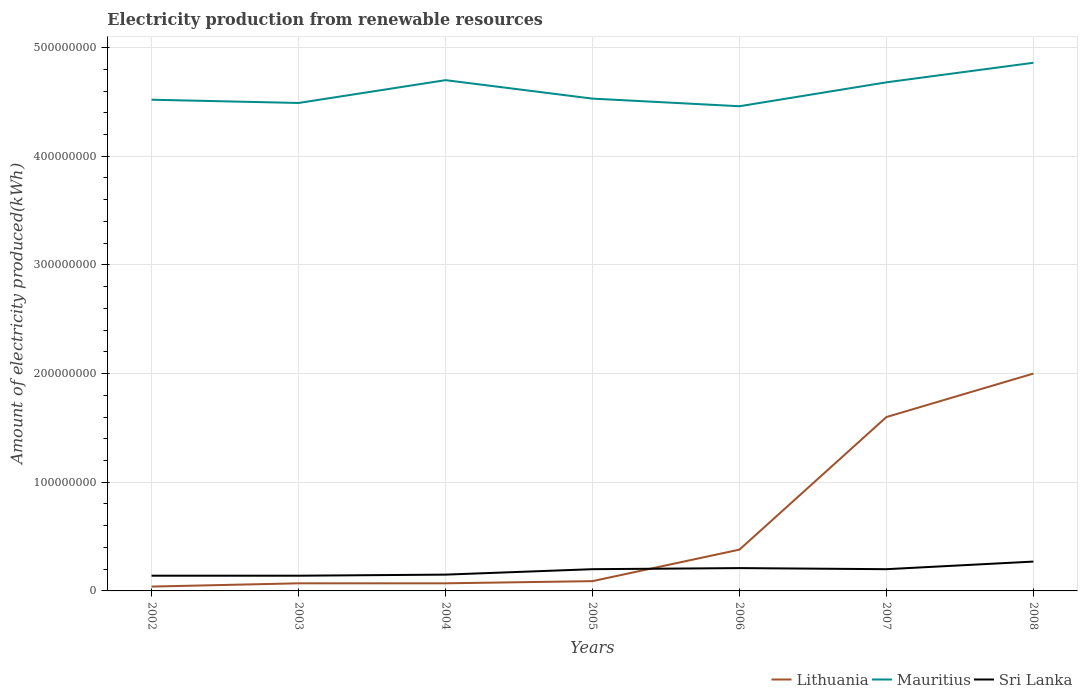How many different coloured lines are there?
Keep it short and to the point. 3. Does the line corresponding to Lithuania intersect with the line corresponding to Mauritius?
Give a very brief answer. No. Across all years, what is the maximum amount of electricity produced in Mauritius?
Your answer should be very brief. 4.46e+08. In which year was the amount of electricity produced in Sri Lanka maximum?
Make the answer very short. 2002. What is the total amount of electricity produced in Mauritius in the graph?
Give a very brief answer. -1.50e+07. What is the difference between the highest and the second highest amount of electricity produced in Sri Lanka?
Provide a succinct answer. 1.30e+07. What is the difference between the highest and the lowest amount of electricity produced in Sri Lanka?
Ensure brevity in your answer.  4. How many lines are there?
Offer a very short reply. 3. How many years are there in the graph?
Offer a very short reply. 7. Are the values on the major ticks of Y-axis written in scientific E-notation?
Provide a short and direct response. No. Does the graph contain any zero values?
Your response must be concise. No. Does the graph contain grids?
Provide a succinct answer. Yes. Where does the legend appear in the graph?
Your answer should be very brief. Bottom right. How are the legend labels stacked?
Ensure brevity in your answer.  Horizontal. What is the title of the graph?
Ensure brevity in your answer.  Electricity production from renewable resources. Does "Latin America(all income levels)" appear as one of the legend labels in the graph?
Provide a succinct answer. No. What is the label or title of the X-axis?
Offer a terse response. Years. What is the label or title of the Y-axis?
Provide a succinct answer. Amount of electricity produced(kWh). What is the Amount of electricity produced(kWh) of Mauritius in 2002?
Provide a succinct answer. 4.52e+08. What is the Amount of electricity produced(kWh) of Sri Lanka in 2002?
Ensure brevity in your answer.  1.40e+07. What is the Amount of electricity produced(kWh) in Lithuania in 2003?
Provide a short and direct response. 7.00e+06. What is the Amount of electricity produced(kWh) in Mauritius in 2003?
Ensure brevity in your answer.  4.49e+08. What is the Amount of electricity produced(kWh) in Sri Lanka in 2003?
Offer a very short reply. 1.40e+07. What is the Amount of electricity produced(kWh) of Lithuania in 2004?
Give a very brief answer. 7.00e+06. What is the Amount of electricity produced(kWh) of Mauritius in 2004?
Your answer should be very brief. 4.70e+08. What is the Amount of electricity produced(kWh) in Sri Lanka in 2004?
Offer a terse response. 1.50e+07. What is the Amount of electricity produced(kWh) of Lithuania in 2005?
Give a very brief answer. 9.00e+06. What is the Amount of electricity produced(kWh) in Mauritius in 2005?
Make the answer very short. 4.53e+08. What is the Amount of electricity produced(kWh) in Lithuania in 2006?
Your response must be concise. 3.80e+07. What is the Amount of electricity produced(kWh) in Mauritius in 2006?
Your answer should be very brief. 4.46e+08. What is the Amount of electricity produced(kWh) in Sri Lanka in 2006?
Provide a succinct answer. 2.10e+07. What is the Amount of electricity produced(kWh) in Lithuania in 2007?
Provide a short and direct response. 1.60e+08. What is the Amount of electricity produced(kWh) in Mauritius in 2007?
Ensure brevity in your answer.  4.68e+08. What is the Amount of electricity produced(kWh) of Sri Lanka in 2007?
Ensure brevity in your answer.  2.00e+07. What is the Amount of electricity produced(kWh) of Mauritius in 2008?
Offer a very short reply. 4.86e+08. What is the Amount of electricity produced(kWh) of Sri Lanka in 2008?
Provide a short and direct response. 2.70e+07. Across all years, what is the maximum Amount of electricity produced(kWh) of Mauritius?
Offer a terse response. 4.86e+08. Across all years, what is the maximum Amount of electricity produced(kWh) of Sri Lanka?
Provide a succinct answer. 2.70e+07. Across all years, what is the minimum Amount of electricity produced(kWh) of Mauritius?
Offer a terse response. 4.46e+08. Across all years, what is the minimum Amount of electricity produced(kWh) in Sri Lanka?
Keep it short and to the point. 1.40e+07. What is the total Amount of electricity produced(kWh) in Lithuania in the graph?
Make the answer very short. 4.25e+08. What is the total Amount of electricity produced(kWh) of Mauritius in the graph?
Provide a succinct answer. 3.22e+09. What is the total Amount of electricity produced(kWh) in Sri Lanka in the graph?
Your answer should be compact. 1.31e+08. What is the difference between the Amount of electricity produced(kWh) in Lithuania in 2002 and that in 2003?
Your answer should be compact. -3.00e+06. What is the difference between the Amount of electricity produced(kWh) of Sri Lanka in 2002 and that in 2003?
Your answer should be compact. 0. What is the difference between the Amount of electricity produced(kWh) in Mauritius in 2002 and that in 2004?
Make the answer very short. -1.80e+07. What is the difference between the Amount of electricity produced(kWh) in Sri Lanka in 2002 and that in 2004?
Your answer should be compact. -1.00e+06. What is the difference between the Amount of electricity produced(kWh) of Lithuania in 2002 and that in 2005?
Give a very brief answer. -5.00e+06. What is the difference between the Amount of electricity produced(kWh) of Mauritius in 2002 and that in 2005?
Provide a short and direct response. -1.00e+06. What is the difference between the Amount of electricity produced(kWh) in Sri Lanka in 2002 and that in 2005?
Provide a succinct answer. -6.00e+06. What is the difference between the Amount of electricity produced(kWh) in Lithuania in 2002 and that in 2006?
Provide a succinct answer. -3.40e+07. What is the difference between the Amount of electricity produced(kWh) in Mauritius in 2002 and that in 2006?
Offer a very short reply. 6.00e+06. What is the difference between the Amount of electricity produced(kWh) of Sri Lanka in 2002 and that in 2006?
Offer a very short reply. -7.00e+06. What is the difference between the Amount of electricity produced(kWh) of Lithuania in 2002 and that in 2007?
Offer a terse response. -1.56e+08. What is the difference between the Amount of electricity produced(kWh) of Mauritius in 2002 and that in 2007?
Provide a succinct answer. -1.60e+07. What is the difference between the Amount of electricity produced(kWh) of Sri Lanka in 2002 and that in 2007?
Make the answer very short. -6.00e+06. What is the difference between the Amount of electricity produced(kWh) of Lithuania in 2002 and that in 2008?
Offer a very short reply. -1.96e+08. What is the difference between the Amount of electricity produced(kWh) of Mauritius in 2002 and that in 2008?
Your answer should be very brief. -3.40e+07. What is the difference between the Amount of electricity produced(kWh) of Sri Lanka in 2002 and that in 2008?
Make the answer very short. -1.30e+07. What is the difference between the Amount of electricity produced(kWh) in Mauritius in 2003 and that in 2004?
Ensure brevity in your answer.  -2.10e+07. What is the difference between the Amount of electricity produced(kWh) of Sri Lanka in 2003 and that in 2004?
Your response must be concise. -1.00e+06. What is the difference between the Amount of electricity produced(kWh) in Lithuania in 2003 and that in 2005?
Your answer should be very brief. -2.00e+06. What is the difference between the Amount of electricity produced(kWh) in Mauritius in 2003 and that in 2005?
Offer a very short reply. -4.00e+06. What is the difference between the Amount of electricity produced(kWh) in Sri Lanka in 2003 and that in 2005?
Provide a short and direct response. -6.00e+06. What is the difference between the Amount of electricity produced(kWh) in Lithuania in 2003 and that in 2006?
Keep it short and to the point. -3.10e+07. What is the difference between the Amount of electricity produced(kWh) in Mauritius in 2003 and that in 2006?
Provide a succinct answer. 3.00e+06. What is the difference between the Amount of electricity produced(kWh) in Sri Lanka in 2003 and that in 2006?
Provide a succinct answer. -7.00e+06. What is the difference between the Amount of electricity produced(kWh) in Lithuania in 2003 and that in 2007?
Keep it short and to the point. -1.53e+08. What is the difference between the Amount of electricity produced(kWh) in Mauritius in 2003 and that in 2007?
Provide a short and direct response. -1.90e+07. What is the difference between the Amount of electricity produced(kWh) in Sri Lanka in 2003 and that in 2007?
Your response must be concise. -6.00e+06. What is the difference between the Amount of electricity produced(kWh) in Lithuania in 2003 and that in 2008?
Ensure brevity in your answer.  -1.93e+08. What is the difference between the Amount of electricity produced(kWh) of Mauritius in 2003 and that in 2008?
Provide a succinct answer. -3.70e+07. What is the difference between the Amount of electricity produced(kWh) in Sri Lanka in 2003 and that in 2008?
Offer a very short reply. -1.30e+07. What is the difference between the Amount of electricity produced(kWh) in Mauritius in 2004 and that in 2005?
Offer a very short reply. 1.70e+07. What is the difference between the Amount of electricity produced(kWh) in Sri Lanka in 2004 and that in 2005?
Make the answer very short. -5.00e+06. What is the difference between the Amount of electricity produced(kWh) of Lithuania in 2004 and that in 2006?
Keep it short and to the point. -3.10e+07. What is the difference between the Amount of electricity produced(kWh) in Mauritius in 2004 and that in 2006?
Provide a succinct answer. 2.40e+07. What is the difference between the Amount of electricity produced(kWh) of Sri Lanka in 2004 and that in 2006?
Keep it short and to the point. -6.00e+06. What is the difference between the Amount of electricity produced(kWh) of Lithuania in 2004 and that in 2007?
Your answer should be compact. -1.53e+08. What is the difference between the Amount of electricity produced(kWh) of Mauritius in 2004 and that in 2007?
Make the answer very short. 2.00e+06. What is the difference between the Amount of electricity produced(kWh) of Sri Lanka in 2004 and that in 2007?
Your answer should be very brief. -5.00e+06. What is the difference between the Amount of electricity produced(kWh) in Lithuania in 2004 and that in 2008?
Your response must be concise. -1.93e+08. What is the difference between the Amount of electricity produced(kWh) of Mauritius in 2004 and that in 2008?
Your answer should be compact. -1.60e+07. What is the difference between the Amount of electricity produced(kWh) in Sri Lanka in 2004 and that in 2008?
Your answer should be compact. -1.20e+07. What is the difference between the Amount of electricity produced(kWh) in Lithuania in 2005 and that in 2006?
Keep it short and to the point. -2.90e+07. What is the difference between the Amount of electricity produced(kWh) of Mauritius in 2005 and that in 2006?
Your answer should be very brief. 7.00e+06. What is the difference between the Amount of electricity produced(kWh) in Sri Lanka in 2005 and that in 2006?
Give a very brief answer. -1.00e+06. What is the difference between the Amount of electricity produced(kWh) of Lithuania in 2005 and that in 2007?
Give a very brief answer. -1.51e+08. What is the difference between the Amount of electricity produced(kWh) of Mauritius in 2005 and that in 2007?
Your answer should be compact. -1.50e+07. What is the difference between the Amount of electricity produced(kWh) in Lithuania in 2005 and that in 2008?
Offer a very short reply. -1.91e+08. What is the difference between the Amount of electricity produced(kWh) in Mauritius in 2005 and that in 2008?
Your answer should be compact. -3.30e+07. What is the difference between the Amount of electricity produced(kWh) of Sri Lanka in 2005 and that in 2008?
Ensure brevity in your answer.  -7.00e+06. What is the difference between the Amount of electricity produced(kWh) in Lithuania in 2006 and that in 2007?
Offer a very short reply. -1.22e+08. What is the difference between the Amount of electricity produced(kWh) in Mauritius in 2006 and that in 2007?
Your response must be concise. -2.20e+07. What is the difference between the Amount of electricity produced(kWh) in Sri Lanka in 2006 and that in 2007?
Make the answer very short. 1.00e+06. What is the difference between the Amount of electricity produced(kWh) of Lithuania in 2006 and that in 2008?
Your answer should be compact. -1.62e+08. What is the difference between the Amount of electricity produced(kWh) in Mauritius in 2006 and that in 2008?
Give a very brief answer. -4.00e+07. What is the difference between the Amount of electricity produced(kWh) of Sri Lanka in 2006 and that in 2008?
Provide a succinct answer. -6.00e+06. What is the difference between the Amount of electricity produced(kWh) in Lithuania in 2007 and that in 2008?
Offer a very short reply. -4.00e+07. What is the difference between the Amount of electricity produced(kWh) of Mauritius in 2007 and that in 2008?
Offer a very short reply. -1.80e+07. What is the difference between the Amount of electricity produced(kWh) in Sri Lanka in 2007 and that in 2008?
Your answer should be compact. -7.00e+06. What is the difference between the Amount of electricity produced(kWh) of Lithuania in 2002 and the Amount of electricity produced(kWh) of Mauritius in 2003?
Make the answer very short. -4.45e+08. What is the difference between the Amount of electricity produced(kWh) of Lithuania in 2002 and the Amount of electricity produced(kWh) of Sri Lanka in 2003?
Provide a short and direct response. -1.00e+07. What is the difference between the Amount of electricity produced(kWh) of Mauritius in 2002 and the Amount of electricity produced(kWh) of Sri Lanka in 2003?
Ensure brevity in your answer.  4.38e+08. What is the difference between the Amount of electricity produced(kWh) of Lithuania in 2002 and the Amount of electricity produced(kWh) of Mauritius in 2004?
Provide a short and direct response. -4.66e+08. What is the difference between the Amount of electricity produced(kWh) in Lithuania in 2002 and the Amount of electricity produced(kWh) in Sri Lanka in 2004?
Keep it short and to the point. -1.10e+07. What is the difference between the Amount of electricity produced(kWh) of Mauritius in 2002 and the Amount of electricity produced(kWh) of Sri Lanka in 2004?
Your answer should be very brief. 4.37e+08. What is the difference between the Amount of electricity produced(kWh) in Lithuania in 2002 and the Amount of electricity produced(kWh) in Mauritius in 2005?
Your answer should be very brief. -4.49e+08. What is the difference between the Amount of electricity produced(kWh) of Lithuania in 2002 and the Amount of electricity produced(kWh) of Sri Lanka in 2005?
Make the answer very short. -1.60e+07. What is the difference between the Amount of electricity produced(kWh) in Mauritius in 2002 and the Amount of electricity produced(kWh) in Sri Lanka in 2005?
Ensure brevity in your answer.  4.32e+08. What is the difference between the Amount of electricity produced(kWh) of Lithuania in 2002 and the Amount of electricity produced(kWh) of Mauritius in 2006?
Your answer should be compact. -4.42e+08. What is the difference between the Amount of electricity produced(kWh) in Lithuania in 2002 and the Amount of electricity produced(kWh) in Sri Lanka in 2006?
Make the answer very short. -1.70e+07. What is the difference between the Amount of electricity produced(kWh) of Mauritius in 2002 and the Amount of electricity produced(kWh) of Sri Lanka in 2006?
Your answer should be very brief. 4.31e+08. What is the difference between the Amount of electricity produced(kWh) of Lithuania in 2002 and the Amount of electricity produced(kWh) of Mauritius in 2007?
Give a very brief answer. -4.64e+08. What is the difference between the Amount of electricity produced(kWh) in Lithuania in 2002 and the Amount of electricity produced(kWh) in Sri Lanka in 2007?
Your answer should be very brief. -1.60e+07. What is the difference between the Amount of electricity produced(kWh) in Mauritius in 2002 and the Amount of electricity produced(kWh) in Sri Lanka in 2007?
Your response must be concise. 4.32e+08. What is the difference between the Amount of electricity produced(kWh) of Lithuania in 2002 and the Amount of electricity produced(kWh) of Mauritius in 2008?
Keep it short and to the point. -4.82e+08. What is the difference between the Amount of electricity produced(kWh) in Lithuania in 2002 and the Amount of electricity produced(kWh) in Sri Lanka in 2008?
Offer a terse response. -2.30e+07. What is the difference between the Amount of electricity produced(kWh) in Mauritius in 2002 and the Amount of electricity produced(kWh) in Sri Lanka in 2008?
Your response must be concise. 4.25e+08. What is the difference between the Amount of electricity produced(kWh) in Lithuania in 2003 and the Amount of electricity produced(kWh) in Mauritius in 2004?
Provide a short and direct response. -4.63e+08. What is the difference between the Amount of electricity produced(kWh) in Lithuania in 2003 and the Amount of electricity produced(kWh) in Sri Lanka in 2004?
Keep it short and to the point. -8.00e+06. What is the difference between the Amount of electricity produced(kWh) in Mauritius in 2003 and the Amount of electricity produced(kWh) in Sri Lanka in 2004?
Make the answer very short. 4.34e+08. What is the difference between the Amount of electricity produced(kWh) in Lithuania in 2003 and the Amount of electricity produced(kWh) in Mauritius in 2005?
Your response must be concise. -4.46e+08. What is the difference between the Amount of electricity produced(kWh) in Lithuania in 2003 and the Amount of electricity produced(kWh) in Sri Lanka in 2005?
Ensure brevity in your answer.  -1.30e+07. What is the difference between the Amount of electricity produced(kWh) of Mauritius in 2003 and the Amount of electricity produced(kWh) of Sri Lanka in 2005?
Give a very brief answer. 4.29e+08. What is the difference between the Amount of electricity produced(kWh) of Lithuania in 2003 and the Amount of electricity produced(kWh) of Mauritius in 2006?
Offer a very short reply. -4.39e+08. What is the difference between the Amount of electricity produced(kWh) of Lithuania in 2003 and the Amount of electricity produced(kWh) of Sri Lanka in 2006?
Provide a short and direct response. -1.40e+07. What is the difference between the Amount of electricity produced(kWh) in Mauritius in 2003 and the Amount of electricity produced(kWh) in Sri Lanka in 2006?
Your response must be concise. 4.28e+08. What is the difference between the Amount of electricity produced(kWh) of Lithuania in 2003 and the Amount of electricity produced(kWh) of Mauritius in 2007?
Make the answer very short. -4.61e+08. What is the difference between the Amount of electricity produced(kWh) in Lithuania in 2003 and the Amount of electricity produced(kWh) in Sri Lanka in 2007?
Give a very brief answer. -1.30e+07. What is the difference between the Amount of electricity produced(kWh) of Mauritius in 2003 and the Amount of electricity produced(kWh) of Sri Lanka in 2007?
Keep it short and to the point. 4.29e+08. What is the difference between the Amount of electricity produced(kWh) of Lithuania in 2003 and the Amount of electricity produced(kWh) of Mauritius in 2008?
Make the answer very short. -4.79e+08. What is the difference between the Amount of electricity produced(kWh) in Lithuania in 2003 and the Amount of electricity produced(kWh) in Sri Lanka in 2008?
Offer a very short reply. -2.00e+07. What is the difference between the Amount of electricity produced(kWh) in Mauritius in 2003 and the Amount of electricity produced(kWh) in Sri Lanka in 2008?
Your response must be concise. 4.22e+08. What is the difference between the Amount of electricity produced(kWh) of Lithuania in 2004 and the Amount of electricity produced(kWh) of Mauritius in 2005?
Provide a succinct answer. -4.46e+08. What is the difference between the Amount of electricity produced(kWh) in Lithuania in 2004 and the Amount of electricity produced(kWh) in Sri Lanka in 2005?
Keep it short and to the point. -1.30e+07. What is the difference between the Amount of electricity produced(kWh) of Mauritius in 2004 and the Amount of electricity produced(kWh) of Sri Lanka in 2005?
Provide a succinct answer. 4.50e+08. What is the difference between the Amount of electricity produced(kWh) of Lithuania in 2004 and the Amount of electricity produced(kWh) of Mauritius in 2006?
Ensure brevity in your answer.  -4.39e+08. What is the difference between the Amount of electricity produced(kWh) of Lithuania in 2004 and the Amount of electricity produced(kWh) of Sri Lanka in 2006?
Ensure brevity in your answer.  -1.40e+07. What is the difference between the Amount of electricity produced(kWh) of Mauritius in 2004 and the Amount of electricity produced(kWh) of Sri Lanka in 2006?
Offer a terse response. 4.49e+08. What is the difference between the Amount of electricity produced(kWh) of Lithuania in 2004 and the Amount of electricity produced(kWh) of Mauritius in 2007?
Your response must be concise. -4.61e+08. What is the difference between the Amount of electricity produced(kWh) of Lithuania in 2004 and the Amount of electricity produced(kWh) of Sri Lanka in 2007?
Provide a succinct answer. -1.30e+07. What is the difference between the Amount of electricity produced(kWh) of Mauritius in 2004 and the Amount of electricity produced(kWh) of Sri Lanka in 2007?
Offer a terse response. 4.50e+08. What is the difference between the Amount of electricity produced(kWh) in Lithuania in 2004 and the Amount of electricity produced(kWh) in Mauritius in 2008?
Ensure brevity in your answer.  -4.79e+08. What is the difference between the Amount of electricity produced(kWh) of Lithuania in 2004 and the Amount of electricity produced(kWh) of Sri Lanka in 2008?
Offer a very short reply. -2.00e+07. What is the difference between the Amount of electricity produced(kWh) in Mauritius in 2004 and the Amount of electricity produced(kWh) in Sri Lanka in 2008?
Make the answer very short. 4.43e+08. What is the difference between the Amount of electricity produced(kWh) of Lithuania in 2005 and the Amount of electricity produced(kWh) of Mauritius in 2006?
Offer a very short reply. -4.37e+08. What is the difference between the Amount of electricity produced(kWh) of Lithuania in 2005 and the Amount of electricity produced(kWh) of Sri Lanka in 2006?
Your answer should be compact. -1.20e+07. What is the difference between the Amount of electricity produced(kWh) in Mauritius in 2005 and the Amount of electricity produced(kWh) in Sri Lanka in 2006?
Provide a short and direct response. 4.32e+08. What is the difference between the Amount of electricity produced(kWh) in Lithuania in 2005 and the Amount of electricity produced(kWh) in Mauritius in 2007?
Your response must be concise. -4.59e+08. What is the difference between the Amount of electricity produced(kWh) of Lithuania in 2005 and the Amount of electricity produced(kWh) of Sri Lanka in 2007?
Offer a very short reply. -1.10e+07. What is the difference between the Amount of electricity produced(kWh) in Mauritius in 2005 and the Amount of electricity produced(kWh) in Sri Lanka in 2007?
Ensure brevity in your answer.  4.33e+08. What is the difference between the Amount of electricity produced(kWh) of Lithuania in 2005 and the Amount of electricity produced(kWh) of Mauritius in 2008?
Offer a very short reply. -4.77e+08. What is the difference between the Amount of electricity produced(kWh) of Lithuania in 2005 and the Amount of electricity produced(kWh) of Sri Lanka in 2008?
Your answer should be very brief. -1.80e+07. What is the difference between the Amount of electricity produced(kWh) in Mauritius in 2005 and the Amount of electricity produced(kWh) in Sri Lanka in 2008?
Your answer should be very brief. 4.26e+08. What is the difference between the Amount of electricity produced(kWh) of Lithuania in 2006 and the Amount of electricity produced(kWh) of Mauritius in 2007?
Offer a very short reply. -4.30e+08. What is the difference between the Amount of electricity produced(kWh) in Lithuania in 2006 and the Amount of electricity produced(kWh) in Sri Lanka in 2007?
Offer a very short reply. 1.80e+07. What is the difference between the Amount of electricity produced(kWh) of Mauritius in 2006 and the Amount of electricity produced(kWh) of Sri Lanka in 2007?
Your response must be concise. 4.26e+08. What is the difference between the Amount of electricity produced(kWh) in Lithuania in 2006 and the Amount of electricity produced(kWh) in Mauritius in 2008?
Your answer should be very brief. -4.48e+08. What is the difference between the Amount of electricity produced(kWh) of Lithuania in 2006 and the Amount of electricity produced(kWh) of Sri Lanka in 2008?
Ensure brevity in your answer.  1.10e+07. What is the difference between the Amount of electricity produced(kWh) in Mauritius in 2006 and the Amount of electricity produced(kWh) in Sri Lanka in 2008?
Keep it short and to the point. 4.19e+08. What is the difference between the Amount of electricity produced(kWh) in Lithuania in 2007 and the Amount of electricity produced(kWh) in Mauritius in 2008?
Your answer should be compact. -3.26e+08. What is the difference between the Amount of electricity produced(kWh) in Lithuania in 2007 and the Amount of electricity produced(kWh) in Sri Lanka in 2008?
Offer a very short reply. 1.33e+08. What is the difference between the Amount of electricity produced(kWh) of Mauritius in 2007 and the Amount of electricity produced(kWh) of Sri Lanka in 2008?
Make the answer very short. 4.41e+08. What is the average Amount of electricity produced(kWh) in Lithuania per year?
Ensure brevity in your answer.  6.07e+07. What is the average Amount of electricity produced(kWh) of Mauritius per year?
Your answer should be compact. 4.61e+08. What is the average Amount of electricity produced(kWh) in Sri Lanka per year?
Provide a succinct answer. 1.87e+07. In the year 2002, what is the difference between the Amount of electricity produced(kWh) in Lithuania and Amount of electricity produced(kWh) in Mauritius?
Your answer should be compact. -4.48e+08. In the year 2002, what is the difference between the Amount of electricity produced(kWh) of Lithuania and Amount of electricity produced(kWh) of Sri Lanka?
Ensure brevity in your answer.  -1.00e+07. In the year 2002, what is the difference between the Amount of electricity produced(kWh) of Mauritius and Amount of electricity produced(kWh) of Sri Lanka?
Your answer should be very brief. 4.38e+08. In the year 2003, what is the difference between the Amount of electricity produced(kWh) in Lithuania and Amount of electricity produced(kWh) in Mauritius?
Provide a succinct answer. -4.42e+08. In the year 2003, what is the difference between the Amount of electricity produced(kWh) in Lithuania and Amount of electricity produced(kWh) in Sri Lanka?
Your answer should be compact. -7.00e+06. In the year 2003, what is the difference between the Amount of electricity produced(kWh) in Mauritius and Amount of electricity produced(kWh) in Sri Lanka?
Offer a very short reply. 4.35e+08. In the year 2004, what is the difference between the Amount of electricity produced(kWh) in Lithuania and Amount of electricity produced(kWh) in Mauritius?
Your response must be concise. -4.63e+08. In the year 2004, what is the difference between the Amount of electricity produced(kWh) of Lithuania and Amount of electricity produced(kWh) of Sri Lanka?
Offer a terse response. -8.00e+06. In the year 2004, what is the difference between the Amount of electricity produced(kWh) of Mauritius and Amount of electricity produced(kWh) of Sri Lanka?
Give a very brief answer. 4.55e+08. In the year 2005, what is the difference between the Amount of electricity produced(kWh) in Lithuania and Amount of electricity produced(kWh) in Mauritius?
Give a very brief answer. -4.44e+08. In the year 2005, what is the difference between the Amount of electricity produced(kWh) in Lithuania and Amount of electricity produced(kWh) in Sri Lanka?
Make the answer very short. -1.10e+07. In the year 2005, what is the difference between the Amount of electricity produced(kWh) of Mauritius and Amount of electricity produced(kWh) of Sri Lanka?
Provide a succinct answer. 4.33e+08. In the year 2006, what is the difference between the Amount of electricity produced(kWh) in Lithuania and Amount of electricity produced(kWh) in Mauritius?
Give a very brief answer. -4.08e+08. In the year 2006, what is the difference between the Amount of electricity produced(kWh) in Lithuania and Amount of electricity produced(kWh) in Sri Lanka?
Your response must be concise. 1.70e+07. In the year 2006, what is the difference between the Amount of electricity produced(kWh) of Mauritius and Amount of electricity produced(kWh) of Sri Lanka?
Your response must be concise. 4.25e+08. In the year 2007, what is the difference between the Amount of electricity produced(kWh) of Lithuania and Amount of electricity produced(kWh) of Mauritius?
Provide a succinct answer. -3.08e+08. In the year 2007, what is the difference between the Amount of electricity produced(kWh) in Lithuania and Amount of electricity produced(kWh) in Sri Lanka?
Keep it short and to the point. 1.40e+08. In the year 2007, what is the difference between the Amount of electricity produced(kWh) in Mauritius and Amount of electricity produced(kWh) in Sri Lanka?
Give a very brief answer. 4.48e+08. In the year 2008, what is the difference between the Amount of electricity produced(kWh) in Lithuania and Amount of electricity produced(kWh) in Mauritius?
Keep it short and to the point. -2.86e+08. In the year 2008, what is the difference between the Amount of electricity produced(kWh) in Lithuania and Amount of electricity produced(kWh) in Sri Lanka?
Provide a succinct answer. 1.73e+08. In the year 2008, what is the difference between the Amount of electricity produced(kWh) of Mauritius and Amount of electricity produced(kWh) of Sri Lanka?
Your response must be concise. 4.59e+08. What is the ratio of the Amount of electricity produced(kWh) in Lithuania in 2002 to that in 2003?
Offer a very short reply. 0.57. What is the ratio of the Amount of electricity produced(kWh) in Mauritius in 2002 to that in 2003?
Provide a succinct answer. 1.01. What is the ratio of the Amount of electricity produced(kWh) of Sri Lanka in 2002 to that in 2003?
Ensure brevity in your answer.  1. What is the ratio of the Amount of electricity produced(kWh) of Mauritius in 2002 to that in 2004?
Provide a succinct answer. 0.96. What is the ratio of the Amount of electricity produced(kWh) in Sri Lanka in 2002 to that in 2004?
Keep it short and to the point. 0.93. What is the ratio of the Amount of electricity produced(kWh) of Lithuania in 2002 to that in 2005?
Your response must be concise. 0.44. What is the ratio of the Amount of electricity produced(kWh) of Lithuania in 2002 to that in 2006?
Make the answer very short. 0.11. What is the ratio of the Amount of electricity produced(kWh) in Mauritius in 2002 to that in 2006?
Offer a very short reply. 1.01. What is the ratio of the Amount of electricity produced(kWh) of Sri Lanka in 2002 to that in 2006?
Offer a terse response. 0.67. What is the ratio of the Amount of electricity produced(kWh) in Lithuania in 2002 to that in 2007?
Ensure brevity in your answer.  0.03. What is the ratio of the Amount of electricity produced(kWh) of Mauritius in 2002 to that in 2007?
Give a very brief answer. 0.97. What is the ratio of the Amount of electricity produced(kWh) of Sri Lanka in 2002 to that in 2007?
Provide a succinct answer. 0.7. What is the ratio of the Amount of electricity produced(kWh) in Lithuania in 2002 to that in 2008?
Your response must be concise. 0.02. What is the ratio of the Amount of electricity produced(kWh) in Sri Lanka in 2002 to that in 2008?
Offer a terse response. 0.52. What is the ratio of the Amount of electricity produced(kWh) of Mauritius in 2003 to that in 2004?
Offer a very short reply. 0.96. What is the ratio of the Amount of electricity produced(kWh) of Sri Lanka in 2003 to that in 2004?
Provide a succinct answer. 0.93. What is the ratio of the Amount of electricity produced(kWh) of Lithuania in 2003 to that in 2005?
Your answer should be compact. 0.78. What is the ratio of the Amount of electricity produced(kWh) in Mauritius in 2003 to that in 2005?
Give a very brief answer. 0.99. What is the ratio of the Amount of electricity produced(kWh) of Lithuania in 2003 to that in 2006?
Keep it short and to the point. 0.18. What is the ratio of the Amount of electricity produced(kWh) of Sri Lanka in 2003 to that in 2006?
Offer a terse response. 0.67. What is the ratio of the Amount of electricity produced(kWh) of Lithuania in 2003 to that in 2007?
Give a very brief answer. 0.04. What is the ratio of the Amount of electricity produced(kWh) in Mauritius in 2003 to that in 2007?
Offer a terse response. 0.96. What is the ratio of the Amount of electricity produced(kWh) of Sri Lanka in 2003 to that in 2007?
Offer a terse response. 0.7. What is the ratio of the Amount of electricity produced(kWh) in Lithuania in 2003 to that in 2008?
Offer a very short reply. 0.04. What is the ratio of the Amount of electricity produced(kWh) in Mauritius in 2003 to that in 2008?
Provide a succinct answer. 0.92. What is the ratio of the Amount of electricity produced(kWh) in Sri Lanka in 2003 to that in 2008?
Provide a succinct answer. 0.52. What is the ratio of the Amount of electricity produced(kWh) in Lithuania in 2004 to that in 2005?
Offer a terse response. 0.78. What is the ratio of the Amount of electricity produced(kWh) of Mauritius in 2004 to that in 2005?
Give a very brief answer. 1.04. What is the ratio of the Amount of electricity produced(kWh) in Lithuania in 2004 to that in 2006?
Provide a short and direct response. 0.18. What is the ratio of the Amount of electricity produced(kWh) in Mauritius in 2004 to that in 2006?
Make the answer very short. 1.05. What is the ratio of the Amount of electricity produced(kWh) of Lithuania in 2004 to that in 2007?
Ensure brevity in your answer.  0.04. What is the ratio of the Amount of electricity produced(kWh) of Mauritius in 2004 to that in 2007?
Ensure brevity in your answer.  1. What is the ratio of the Amount of electricity produced(kWh) in Lithuania in 2004 to that in 2008?
Your answer should be very brief. 0.04. What is the ratio of the Amount of electricity produced(kWh) in Mauritius in 2004 to that in 2008?
Your answer should be compact. 0.97. What is the ratio of the Amount of electricity produced(kWh) in Sri Lanka in 2004 to that in 2008?
Make the answer very short. 0.56. What is the ratio of the Amount of electricity produced(kWh) in Lithuania in 2005 to that in 2006?
Provide a short and direct response. 0.24. What is the ratio of the Amount of electricity produced(kWh) of Mauritius in 2005 to that in 2006?
Make the answer very short. 1.02. What is the ratio of the Amount of electricity produced(kWh) of Sri Lanka in 2005 to that in 2006?
Provide a succinct answer. 0.95. What is the ratio of the Amount of electricity produced(kWh) in Lithuania in 2005 to that in 2007?
Your answer should be compact. 0.06. What is the ratio of the Amount of electricity produced(kWh) of Mauritius in 2005 to that in 2007?
Keep it short and to the point. 0.97. What is the ratio of the Amount of electricity produced(kWh) in Sri Lanka in 2005 to that in 2007?
Ensure brevity in your answer.  1. What is the ratio of the Amount of electricity produced(kWh) of Lithuania in 2005 to that in 2008?
Keep it short and to the point. 0.04. What is the ratio of the Amount of electricity produced(kWh) of Mauritius in 2005 to that in 2008?
Offer a terse response. 0.93. What is the ratio of the Amount of electricity produced(kWh) of Sri Lanka in 2005 to that in 2008?
Provide a succinct answer. 0.74. What is the ratio of the Amount of electricity produced(kWh) of Lithuania in 2006 to that in 2007?
Offer a very short reply. 0.24. What is the ratio of the Amount of electricity produced(kWh) in Mauritius in 2006 to that in 2007?
Offer a terse response. 0.95. What is the ratio of the Amount of electricity produced(kWh) in Sri Lanka in 2006 to that in 2007?
Make the answer very short. 1.05. What is the ratio of the Amount of electricity produced(kWh) in Lithuania in 2006 to that in 2008?
Provide a short and direct response. 0.19. What is the ratio of the Amount of electricity produced(kWh) in Mauritius in 2006 to that in 2008?
Provide a succinct answer. 0.92. What is the ratio of the Amount of electricity produced(kWh) in Mauritius in 2007 to that in 2008?
Offer a very short reply. 0.96. What is the ratio of the Amount of electricity produced(kWh) in Sri Lanka in 2007 to that in 2008?
Provide a succinct answer. 0.74. What is the difference between the highest and the second highest Amount of electricity produced(kWh) of Lithuania?
Your answer should be compact. 4.00e+07. What is the difference between the highest and the second highest Amount of electricity produced(kWh) of Mauritius?
Give a very brief answer. 1.60e+07. What is the difference between the highest and the second highest Amount of electricity produced(kWh) in Sri Lanka?
Make the answer very short. 6.00e+06. What is the difference between the highest and the lowest Amount of electricity produced(kWh) in Lithuania?
Give a very brief answer. 1.96e+08. What is the difference between the highest and the lowest Amount of electricity produced(kWh) in Mauritius?
Keep it short and to the point. 4.00e+07. What is the difference between the highest and the lowest Amount of electricity produced(kWh) of Sri Lanka?
Offer a terse response. 1.30e+07. 